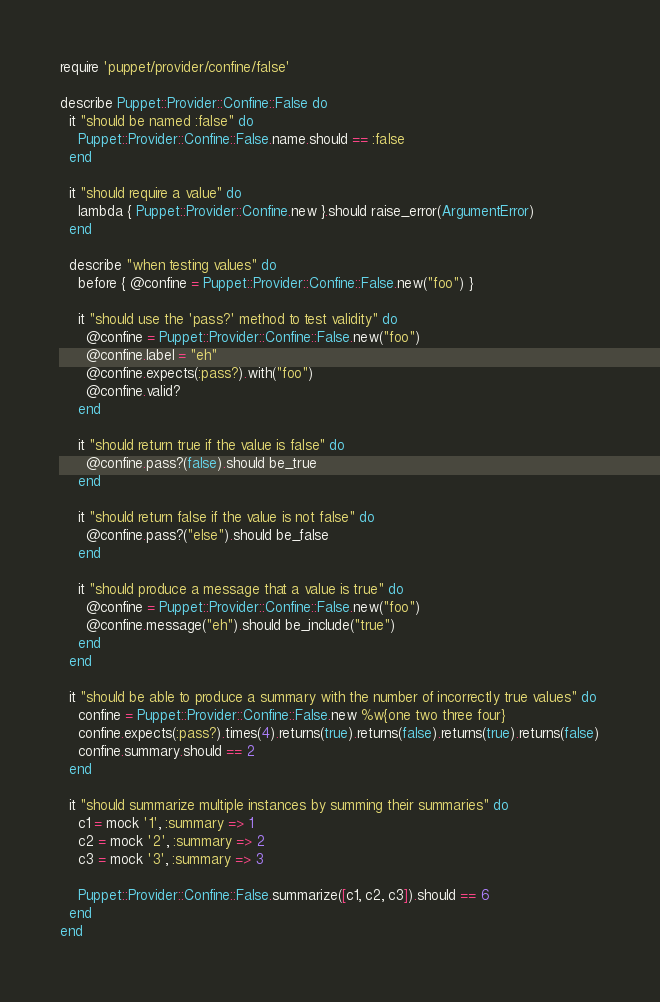Convert code to text. <code><loc_0><loc_0><loc_500><loc_500><_Ruby_>require 'puppet/provider/confine/false'

describe Puppet::Provider::Confine::False do
  it "should be named :false" do
    Puppet::Provider::Confine::False.name.should == :false
  end

  it "should require a value" do
    lambda { Puppet::Provider::Confine.new }.should raise_error(ArgumentError)
  end

  describe "when testing values" do
    before { @confine = Puppet::Provider::Confine::False.new("foo") }

    it "should use the 'pass?' method to test validity" do
      @confine = Puppet::Provider::Confine::False.new("foo")
      @confine.label = "eh"
      @confine.expects(:pass?).with("foo")
      @confine.valid?
    end

    it "should return true if the value is false" do
      @confine.pass?(false).should be_true
    end

    it "should return false if the value is not false" do
      @confine.pass?("else").should be_false
    end

    it "should produce a message that a value is true" do
      @confine = Puppet::Provider::Confine::False.new("foo")
      @confine.message("eh").should be_include("true")
    end
  end

  it "should be able to produce a summary with the number of incorrectly true values" do
    confine = Puppet::Provider::Confine::False.new %w{one two three four}
    confine.expects(:pass?).times(4).returns(true).returns(false).returns(true).returns(false)
    confine.summary.should == 2
  end

  it "should summarize multiple instances by summing their summaries" do
    c1 = mock '1', :summary => 1
    c2 = mock '2', :summary => 2
    c3 = mock '3', :summary => 3

    Puppet::Provider::Confine::False.summarize([c1, c2, c3]).should == 6
  end
end
</code> 